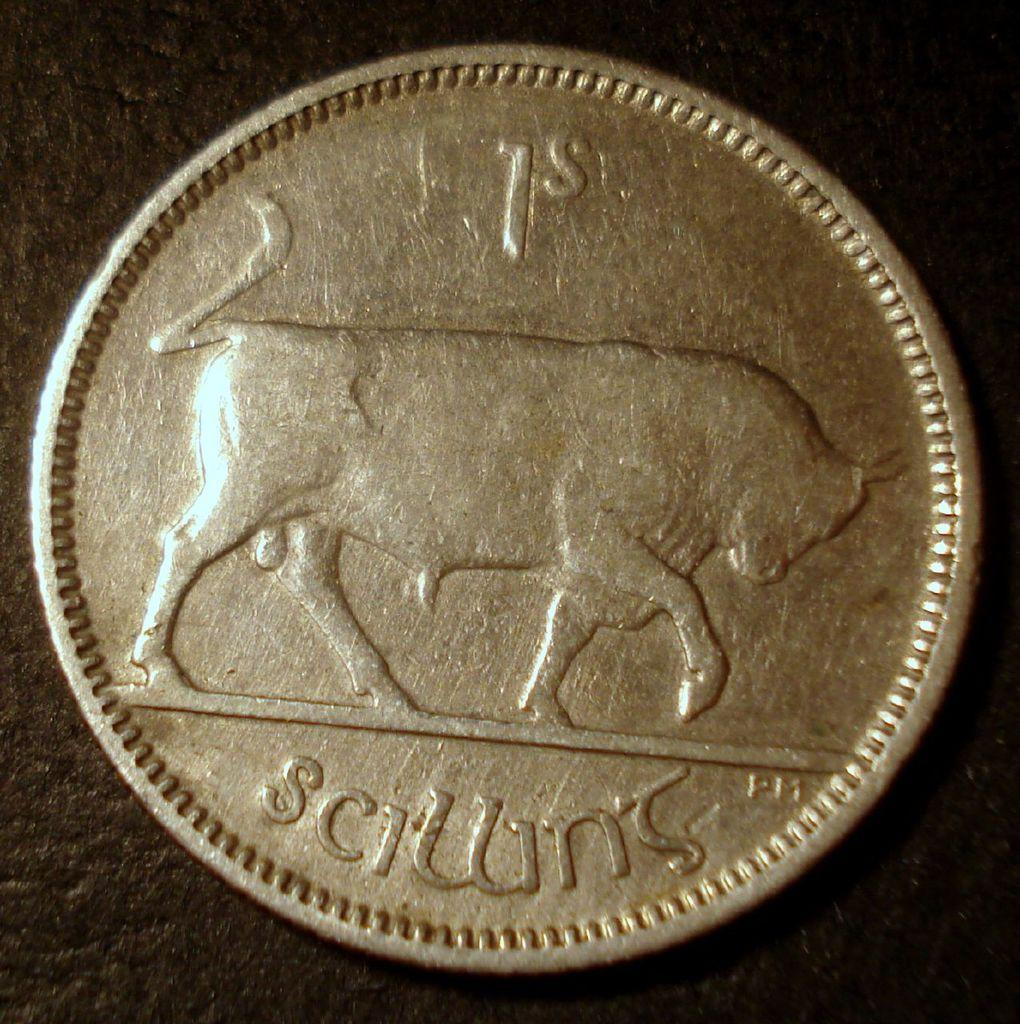<image>
Write a terse but informative summary of the picture. A silvery coin shows the side of a bull with 1s on top. 